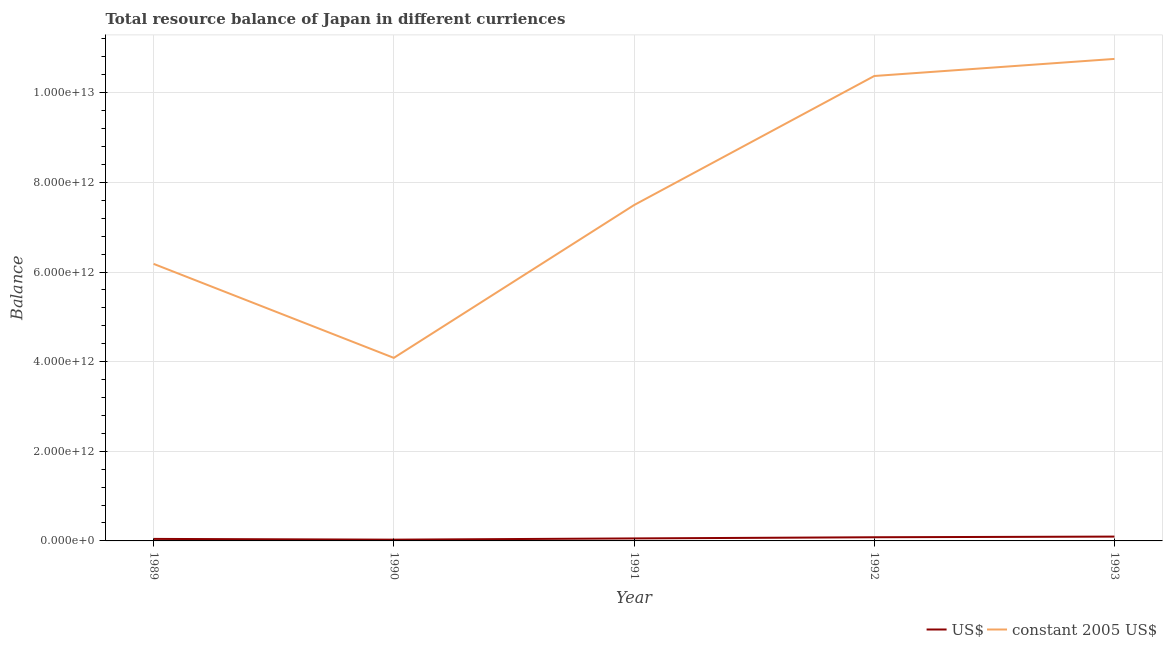Does the line corresponding to resource balance in constant us$ intersect with the line corresponding to resource balance in us$?
Your answer should be very brief. No. Is the number of lines equal to the number of legend labels?
Keep it short and to the point. Yes. What is the resource balance in us$ in 1991?
Offer a very short reply. 5.56e+1. Across all years, what is the maximum resource balance in constant us$?
Offer a terse response. 1.08e+13. Across all years, what is the minimum resource balance in constant us$?
Keep it short and to the point. 4.08e+12. What is the total resource balance in constant us$ in the graph?
Ensure brevity in your answer.  3.89e+13. What is the difference between the resource balance in us$ in 1990 and that in 1993?
Provide a succinct answer. -6.85e+1. What is the difference between the resource balance in us$ in 1993 and the resource balance in constant us$ in 1992?
Offer a terse response. -1.03e+13. What is the average resource balance in us$ per year?
Provide a succinct answer. 6.14e+1. In the year 1993, what is the difference between the resource balance in constant us$ and resource balance in us$?
Ensure brevity in your answer.  1.07e+13. What is the ratio of the resource balance in us$ in 1990 to that in 1992?
Offer a very short reply. 0.34. Is the difference between the resource balance in us$ in 1989 and 1992 greater than the difference between the resource balance in constant us$ in 1989 and 1992?
Offer a terse response. Yes. What is the difference between the highest and the second highest resource balance in constant us$?
Your response must be concise. 3.81e+11. What is the difference between the highest and the lowest resource balance in constant us$?
Your response must be concise. 6.67e+12. Is the sum of the resource balance in constant us$ in 1991 and 1992 greater than the maximum resource balance in us$ across all years?
Give a very brief answer. Yes. Does the resource balance in us$ monotonically increase over the years?
Offer a very short reply. No. Is the resource balance in constant us$ strictly greater than the resource balance in us$ over the years?
Your response must be concise. Yes. Is the resource balance in constant us$ strictly less than the resource balance in us$ over the years?
Provide a succinct answer. No. How many lines are there?
Offer a very short reply. 2. What is the difference between two consecutive major ticks on the Y-axis?
Offer a terse response. 2.00e+12. Does the graph contain any zero values?
Ensure brevity in your answer.  No. How many legend labels are there?
Keep it short and to the point. 2. What is the title of the graph?
Provide a short and direct response. Total resource balance of Japan in different curriences. Does "Mobile cellular" appear as one of the legend labels in the graph?
Provide a succinct answer. No. What is the label or title of the Y-axis?
Your answer should be very brief. Balance. What is the Balance in US$ in 1989?
Provide a succinct answer. 4.48e+1. What is the Balance in constant 2005 US$ in 1989?
Provide a succinct answer. 6.18e+12. What is the Balance of US$ in 1990?
Your response must be concise. 2.82e+1. What is the Balance of constant 2005 US$ in 1990?
Ensure brevity in your answer.  4.08e+12. What is the Balance of US$ in 1991?
Ensure brevity in your answer.  5.56e+1. What is the Balance in constant 2005 US$ in 1991?
Keep it short and to the point. 7.49e+12. What is the Balance of US$ in 1992?
Provide a short and direct response. 8.19e+1. What is the Balance of constant 2005 US$ in 1992?
Offer a very short reply. 1.04e+13. What is the Balance in US$ in 1993?
Your answer should be compact. 9.67e+1. What is the Balance of constant 2005 US$ in 1993?
Ensure brevity in your answer.  1.08e+13. Across all years, what is the maximum Balance of US$?
Make the answer very short. 9.67e+1. Across all years, what is the maximum Balance in constant 2005 US$?
Offer a terse response. 1.08e+13. Across all years, what is the minimum Balance in US$?
Your answer should be very brief. 2.82e+1. Across all years, what is the minimum Balance in constant 2005 US$?
Your response must be concise. 4.08e+12. What is the total Balance in US$ in the graph?
Provide a succinct answer. 3.07e+11. What is the total Balance in constant 2005 US$ in the graph?
Make the answer very short. 3.89e+13. What is the difference between the Balance of US$ in 1989 and that in 1990?
Offer a terse response. 1.66e+1. What is the difference between the Balance in constant 2005 US$ in 1989 and that in 1990?
Ensure brevity in your answer.  2.10e+12. What is the difference between the Balance of US$ in 1989 and that in 1991?
Give a very brief answer. -1.08e+1. What is the difference between the Balance of constant 2005 US$ in 1989 and that in 1991?
Your response must be concise. -1.31e+12. What is the difference between the Balance in US$ in 1989 and that in 1992?
Provide a succinct answer. -3.71e+1. What is the difference between the Balance in constant 2005 US$ in 1989 and that in 1992?
Offer a very short reply. -4.19e+12. What is the difference between the Balance in US$ in 1989 and that in 1993?
Provide a succinct answer. -5.19e+1. What is the difference between the Balance of constant 2005 US$ in 1989 and that in 1993?
Your response must be concise. -4.57e+12. What is the difference between the Balance in US$ in 1990 and that in 1991?
Your answer should be compact. -2.74e+1. What is the difference between the Balance of constant 2005 US$ in 1990 and that in 1991?
Give a very brief answer. -3.41e+12. What is the difference between the Balance in US$ in 1990 and that in 1992?
Make the answer very short. -5.37e+1. What is the difference between the Balance of constant 2005 US$ in 1990 and that in 1992?
Your answer should be very brief. -6.29e+12. What is the difference between the Balance of US$ in 1990 and that in 1993?
Ensure brevity in your answer.  -6.85e+1. What is the difference between the Balance of constant 2005 US$ in 1990 and that in 1993?
Give a very brief answer. -6.67e+12. What is the difference between the Balance of US$ in 1991 and that in 1992?
Offer a very short reply. -2.63e+1. What is the difference between the Balance of constant 2005 US$ in 1991 and that in 1992?
Give a very brief answer. -2.88e+12. What is the difference between the Balance in US$ in 1991 and that in 1993?
Your answer should be very brief. -4.11e+1. What is the difference between the Balance of constant 2005 US$ in 1991 and that in 1993?
Offer a terse response. -3.26e+12. What is the difference between the Balance in US$ in 1992 and that in 1993?
Provide a short and direct response. -1.48e+1. What is the difference between the Balance in constant 2005 US$ in 1992 and that in 1993?
Make the answer very short. -3.81e+11. What is the difference between the Balance in US$ in 1989 and the Balance in constant 2005 US$ in 1990?
Offer a very short reply. -4.04e+12. What is the difference between the Balance in US$ in 1989 and the Balance in constant 2005 US$ in 1991?
Make the answer very short. -7.45e+12. What is the difference between the Balance of US$ in 1989 and the Balance of constant 2005 US$ in 1992?
Offer a terse response. -1.03e+13. What is the difference between the Balance of US$ in 1989 and the Balance of constant 2005 US$ in 1993?
Make the answer very short. -1.07e+13. What is the difference between the Balance of US$ in 1990 and the Balance of constant 2005 US$ in 1991?
Make the answer very short. -7.46e+12. What is the difference between the Balance in US$ in 1990 and the Balance in constant 2005 US$ in 1992?
Offer a very short reply. -1.03e+13. What is the difference between the Balance of US$ in 1990 and the Balance of constant 2005 US$ in 1993?
Your response must be concise. -1.07e+13. What is the difference between the Balance of US$ in 1991 and the Balance of constant 2005 US$ in 1992?
Your response must be concise. -1.03e+13. What is the difference between the Balance in US$ in 1991 and the Balance in constant 2005 US$ in 1993?
Provide a short and direct response. -1.07e+13. What is the difference between the Balance in US$ in 1992 and the Balance in constant 2005 US$ in 1993?
Keep it short and to the point. -1.07e+13. What is the average Balance in US$ per year?
Ensure brevity in your answer.  6.14e+1. What is the average Balance of constant 2005 US$ per year?
Your answer should be very brief. 7.78e+12. In the year 1989, what is the difference between the Balance of US$ and Balance of constant 2005 US$?
Provide a short and direct response. -6.14e+12. In the year 1990, what is the difference between the Balance of US$ and Balance of constant 2005 US$?
Provide a succinct answer. -4.06e+12. In the year 1991, what is the difference between the Balance in US$ and Balance in constant 2005 US$?
Offer a terse response. -7.44e+12. In the year 1992, what is the difference between the Balance of US$ and Balance of constant 2005 US$?
Ensure brevity in your answer.  -1.03e+13. In the year 1993, what is the difference between the Balance of US$ and Balance of constant 2005 US$?
Give a very brief answer. -1.07e+13. What is the ratio of the Balance in US$ in 1989 to that in 1990?
Make the answer very short. 1.59. What is the ratio of the Balance in constant 2005 US$ in 1989 to that in 1990?
Make the answer very short. 1.51. What is the ratio of the Balance of US$ in 1989 to that in 1991?
Offer a terse response. 0.81. What is the ratio of the Balance of constant 2005 US$ in 1989 to that in 1991?
Give a very brief answer. 0.82. What is the ratio of the Balance in US$ in 1989 to that in 1992?
Keep it short and to the point. 0.55. What is the ratio of the Balance in constant 2005 US$ in 1989 to that in 1992?
Ensure brevity in your answer.  0.6. What is the ratio of the Balance of US$ in 1989 to that in 1993?
Provide a short and direct response. 0.46. What is the ratio of the Balance in constant 2005 US$ in 1989 to that in 1993?
Make the answer very short. 0.57. What is the ratio of the Balance of US$ in 1990 to that in 1991?
Your response must be concise. 0.51. What is the ratio of the Balance in constant 2005 US$ in 1990 to that in 1991?
Provide a succinct answer. 0.55. What is the ratio of the Balance in US$ in 1990 to that in 1992?
Provide a succinct answer. 0.34. What is the ratio of the Balance of constant 2005 US$ in 1990 to that in 1992?
Keep it short and to the point. 0.39. What is the ratio of the Balance of US$ in 1990 to that in 1993?
Make the answer very short. 0.29. What is the ratio of the Balance of constant 2005 US$ in 1990 to that in 1993?
Provide a short and direct response. 0.38. What is the ratio of the Balance of US$ in 1991 to that in 1992?
Offer a terse response. 0.68. What is the ratio of the Balance in constant 2005 US$ in 1991 to that in 1992?
Offer a very short reply. 0.72. What is the ratio of the Balance in US$ in 1991 to that in 1993?
Make the answer very short. 0.58. What is the ratio of the Balance of constant 2005 US$ in 1991 to that in 1993?
Make the answer very short. 0.7. What is the ratio of the Balance in US$ in 1992 to that in 1993?
Your response must be concise. 0.85. What is the ratio of the Balance in constant 2005 US$ in 1992 to that in 1993?
Your response must be concise. 0.96. What is the difference between the highest and the second highest Balance in US$?
Offer a terse response. 1.48e+1. What is the difference between the highest and the second highest Balance in constant 2005 US$?
Your answer should be very brief. 3.81e+11. What is the difference between the highest and the lowest Balance of US$?
Provide a short and direct response. 6.85e+1. What is the difference between the highest and the lowest Balance of constant 2005 US$?
Offer a very short reply. 6.67e+12. 